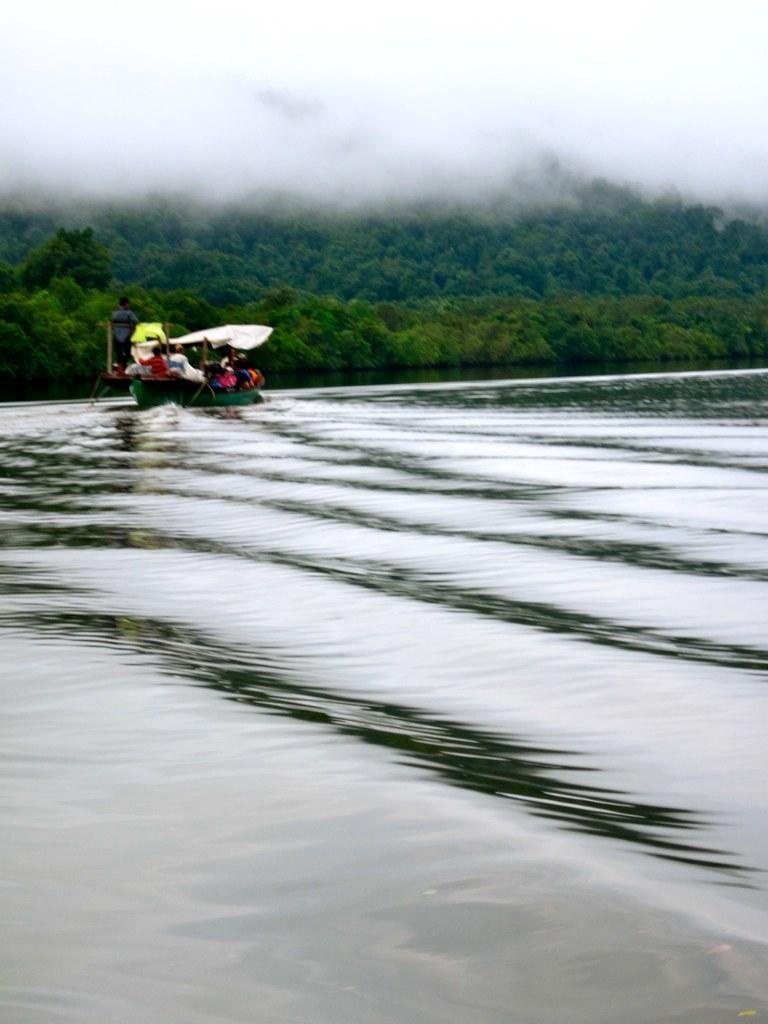How would you summarize this image in a sentence or two? In the picture we can see water on it we can see a boat with some people sitting on it and in the background we can see plants, trees and fog. 